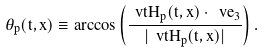<formula> <loc_0><loc_0><loc_500><loc_500>\theta _ { p } ( t , x ) \equiv \arccos \left ( \frac { \ v t H _ { p } ( t , x ) \cdot \ v e _ { 3 } } { | \ v t H _ { p } ( t , x ) | } \right ) .</formula> 